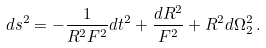<formula> <loc_0><loc_0><loc_500><loc_500>d s ^ { 2 } = - \frac { 1 } { R ^ { 2 } F ^ { 2 } } d t ^ { 2 } + \frac { d R ^ { 2 } } { F ^ { 2 } } + R ^ { 2 } d \Omega _ { 2 } ^ { 2 } \, .</formula> 